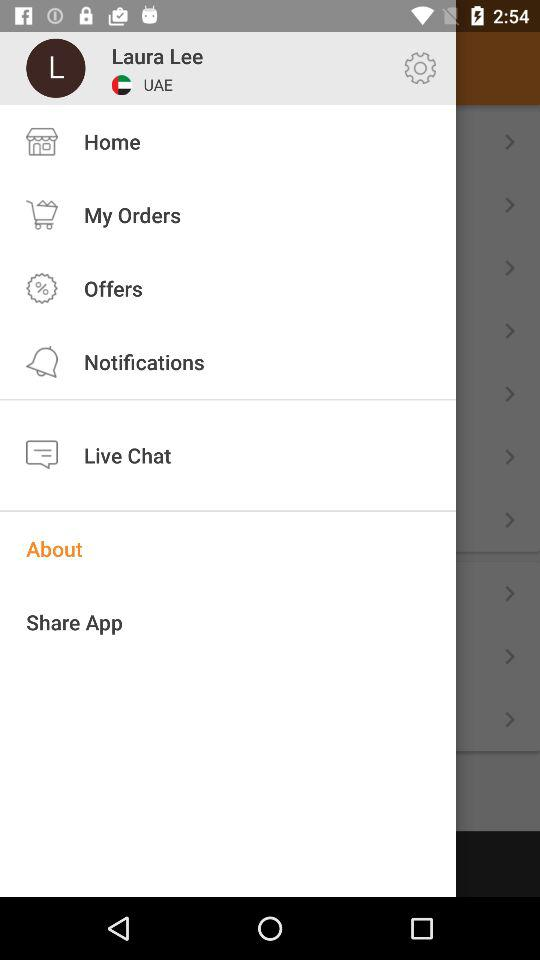What is the country name of the user? The name of the country is the UAE. 